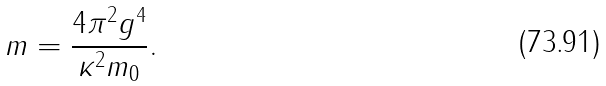<formula> <loc_0><loc_0><loc_500><loc_500>m = \frac { 4 \pi ^ { 2 } g ^ { 4 } } { \kappa ^ { 2 } m _ { 0 } } .</formula> 